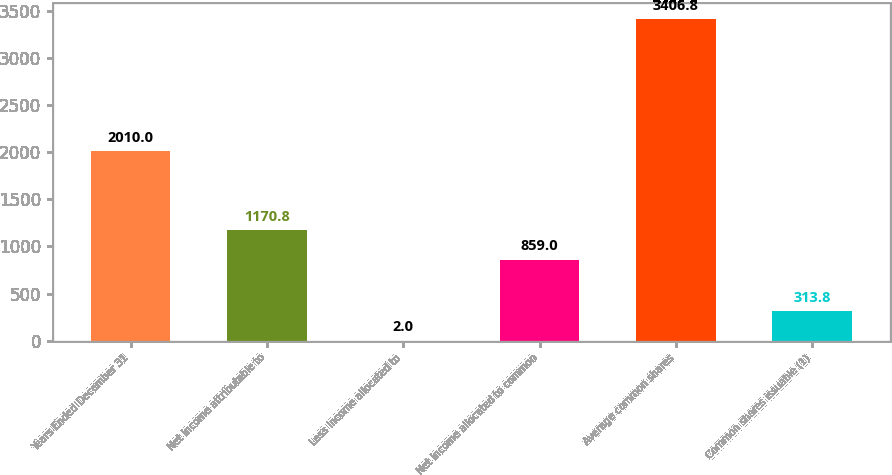<chart> <loc_0><loc_0><loc_500><loc_500><bar_chart><fcel>Years Ended December 31<fcel>Net income attributable to<fcel>Less Income allocated to<fcel>Net income allocated to common<fcel>Average common shares<fcel>Common shares issuable (1)<nl><fcel>2010<fcel>1170.8<fcel>2<fcel>859<fcel>3406.8<fcel>313.8<nl></chart> 